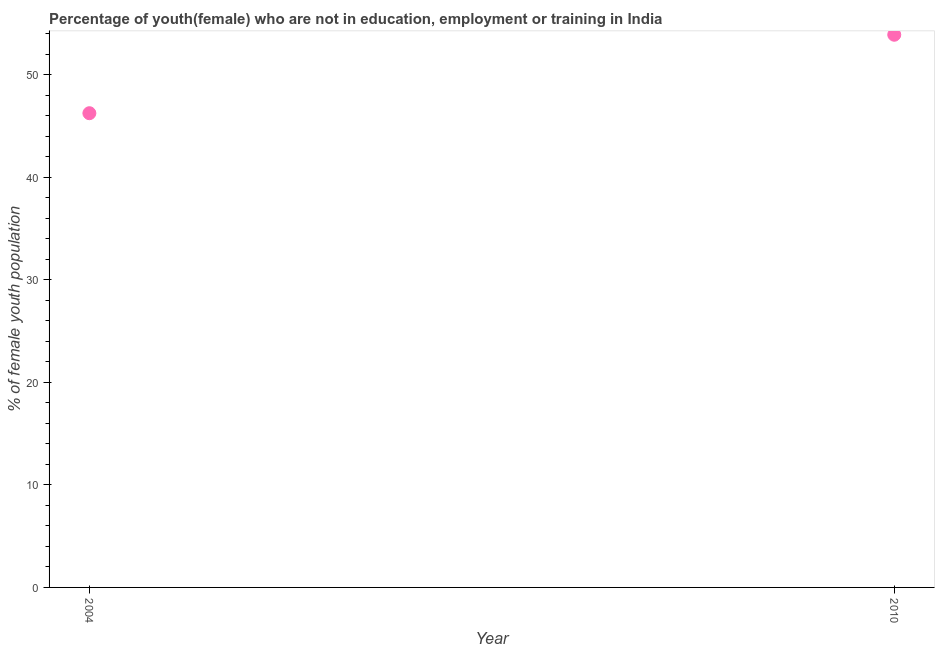What is the unemployed female youth population in 2010?
Your response must be concise. 53.89. Across all years, what is the maximum unemployed female youth population?
Your answer should be compact. 53.89. Across all years, what is the minimum unemployed female youth population?
Keep it short and to the point. 46.24. What is the sum of the unemployed female youth population?
Offer a terse response. 100.13. What is the difference between the unemployed female youth population in 2004 and 2010?
Make the answer very short. -7.65. What is the average unemployed female youth population per year?
Offer a very short reply. 50.07. What is the median unemployed female youth population?
Your answer should be very brief. 50.07. In how many years, is the unemployed female youth population greater than 8 %?
Ensure brevity in your answer.  2. Do a majority of the years between 2004 and 2010 (inclusive) have unemployed female youth population greater than 14 %?
Provide a short and direct response. Yes. What is the ratio of the unemployed female youth population in 2004 to that in 2010?
Ensure brevity in your answer.  0.86. How many years are there in the graph?
Provide a short and direct response. 2. Does the graph contain grids?
Your answer should be very brief. No. What is the title of the graph?
Your answer should be very brief. Percentage of youth(female) who are not in education, employment or training in India. What is the label or title of the X-axis?
Offer a terse response. Year. What is the label or title of the Y-axis?
Provide a succinct answer. % of female youth population. What is the % of female youth population in 2004?
Your answer should be compact. 46.24. What is the % of female youth population in 2010?
Give a very brief answer. 53.89. What is the difference between the % of female youth population in 2004 and 2010?
Your answer should be compact. -7.65. What is the ratio of the % of female youth population in 2004 to that in 2010?
Make the answer very short. 0.86. 